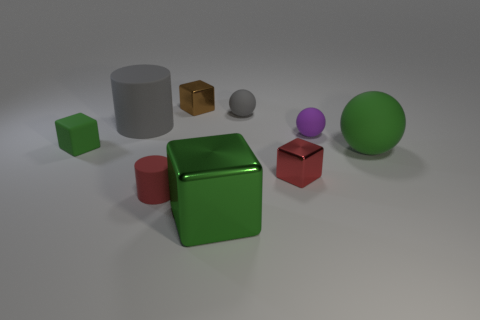The matte sphere that is the same color as the large shiny thing is what size?
Provide a short and direct response. Large. Do the big metallic object and the small rubber cube have the same color?
Your answer should be very brief. Yes. Does the metallic object in front of the red cylinder have the same color as the tiny rubber cube?
Make the answer very short. Yes. How many other objects are there of the same size as the gray rubber cylinder?
Your answer should be compact. 2. Is the material of the cylinder that is behind the big rubber ball the same as the red object to the left of the tiny gray object?
Your answer should be compact. Yes. What is the color of the cylinder that is the same size as the green metal cube?
Offer a terse response. Gray. Are there any other things of the same color as the small matte cylinder?
Offer a very short reply. Yes. What size is the red object that is on the left side of the tiny metal object that is behind the big green thing right of the gray rubber ball?
Your answer should be compact. Small. The big thing that is on the left side of the tiny purple object and to the right of the gray rubber cylinder is what color?
Keep it short and to the point. Green. How big is the shiny thing in front of the red shiny block?
Offer a terse response. Large. 